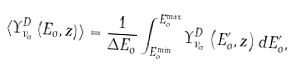Convert formula to latex. <formula><loc_0><loc_0><loc_500><loc_500>\langle \Upsilon _ { \nu _ { \alpha } } ^ { D } \left ( E _ { o } , z \right ) \rangle = \frac { 1 } { \Delta E _ { o } } \int _ { E _ { o } ^ { \min } } ^ { E _ { o } ^ { \max } } \Upsilon _ { \nu _ { \alpha } } ^ { D } \left ( E _ { o } ^ { \prime } , z \right ) d E _ { o } ^ { \prime } ,</formula> 